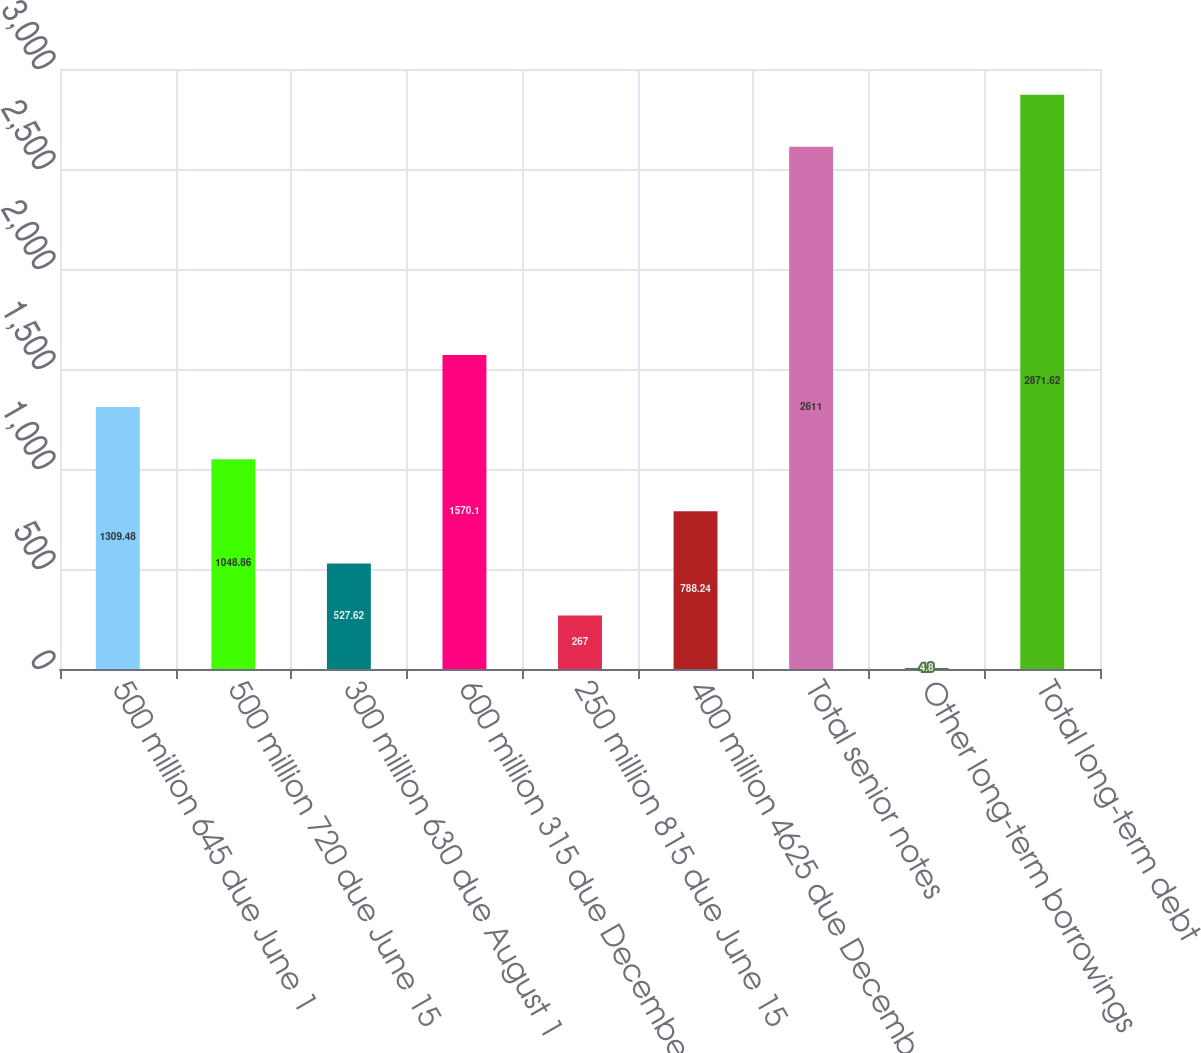Convert chart. <chart><loc_0><loc_0><loc_500><loc_500><bar_chart><fcel>500 million 645 due June 1<fcel>500 million 720 due June 15<fcel>300 million 630 due August 1<fcel>600 million 315 due December 1<fcel>250 million 815 due June 15<fcel>400 million 4625 due December<fcel>Total senior notes<fcel>Other long-term borrowings<fcel>Total long-term debt<nl><fcel>1309.48<fcel>1048.86<fcel>527.62<fcel>1570.1<fcel>267<fcel>788.24<fcel>2611<fcel>4.8<fcel>2871.62<nl></chart> 